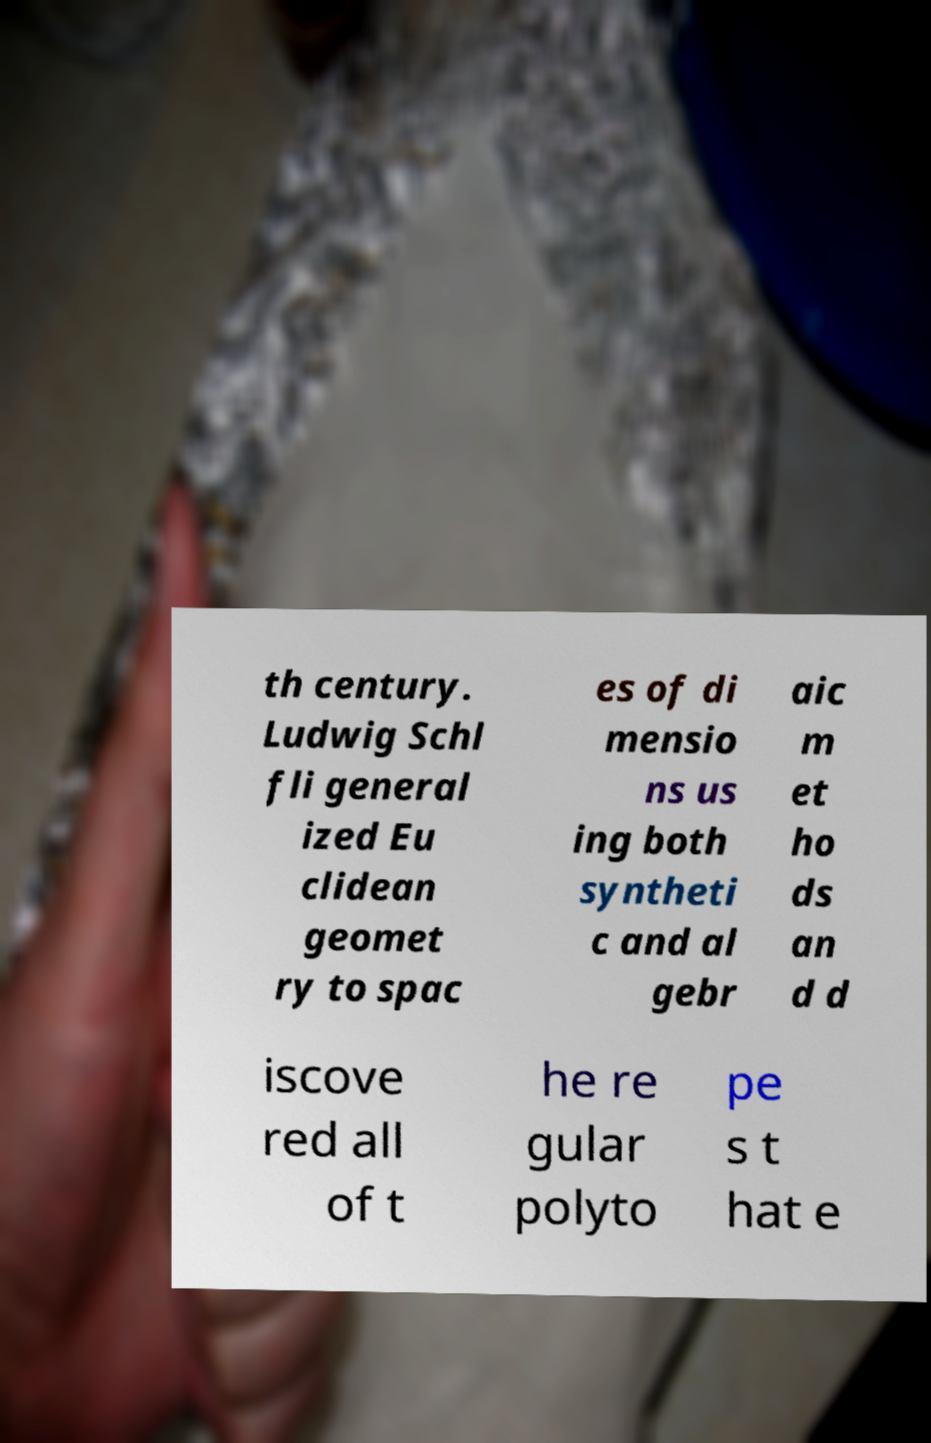Can you accurately transcribe the text from the provided image for me? th century. Ludwig Schl fli general ized Eu clidean geomet ry to spac es of di mensio ns us ing both syntheti c and al gebr aic m et ho ds an d d iscove red all of t he re gular polyto pe s t hat e 